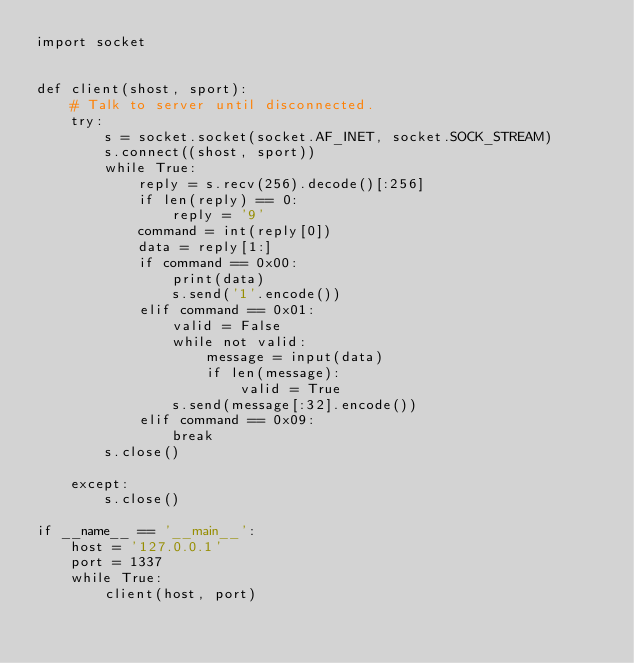<code> <loc_0><loc_0><loc_500><loc_500><_Python_>import socket


def client(shost, sport):
    # Talk to server until disconnected.
    try:
        s = socket.socket(socket.AF_INET, socket.SOCK_STREAM)
        s.connect((shost, sport))
        while True:
            reply = s.recv(256).decode()[:256]
            if len(reply) == 0:
                reply = '9'
            command = int(reply[0])
            data = reply[1:]
            if command == 0x00:
                print(data)
                s.send('1'.encode())
            elif command == 0x01:
                valid = False
                while not valid:
                    message = input(data)
                    if len(message):
                        valid = True
                s.send(message[:32].encode())
            elif command == 0x09:
                break
        s.close()

    except:
        s.close()

if __name__ == '__main__':
    host = '127.0.0.1'
    port = 1337
    while True:
        client(host, port)
</code> 